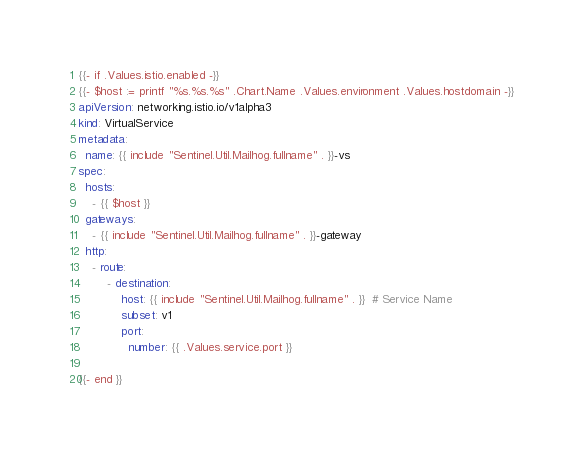<code> <loc_0><loc_0><loc_500><loc_500><_YAML_>{{- if .Values.istio.enabled -}}
{{- $host := printf "%s.%s.%s" .Chart.Name .Values.environment .Values.hostdomain -}}
apiVersion: networking.istio.io/v1alpha3
kind: VirtualService
metadata:
  name: {{ include "Sentinel.Util.Mailhog.fullname" . }}-vs
spec:
  hosts:
    - {{ $host }}
  gateways:
    - {{ include "Sentinel.Util.Mailhog.fullname" . }}-gateway
  http:
    - route:
        - destination:
            host: {{ include "Sentinel.Util.Mailhog.fullname" . }}  # Service Name
            subset: v1
            port:
              number: {{ .Values.service.port }}

{{- end }}</code> 